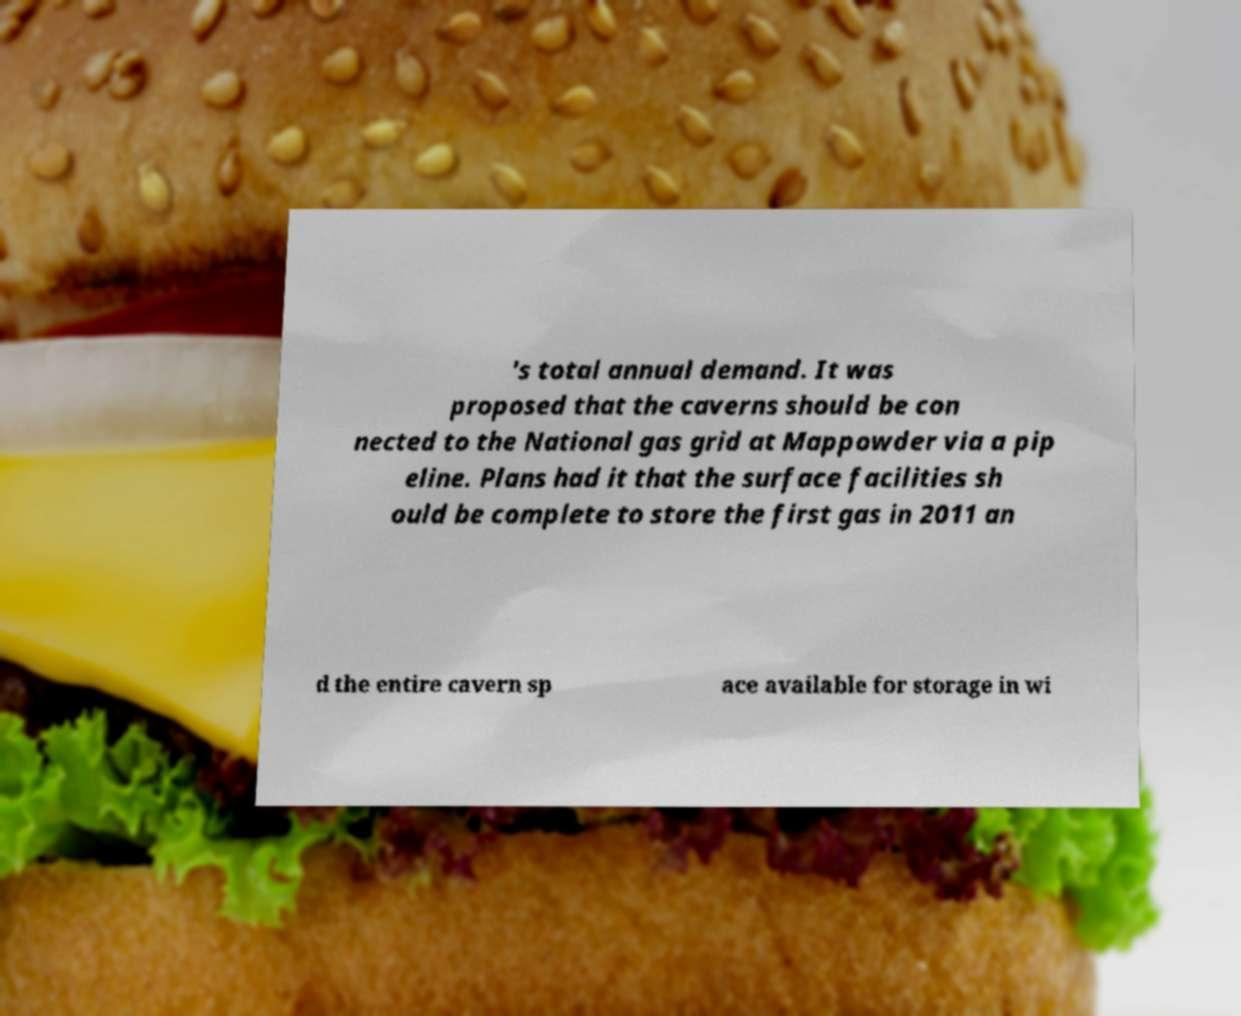Could you assist in decoding the text presented in this image and type it out clearly? 's total annual demand. It was proposed that the caverns should be con nected to the National gas grid at Mappowder via a pip eline. Plans had it that the surface facilities sh ould be complete to store the first gas in 2011 an d the entire cavern sp ace available for storage in wi 